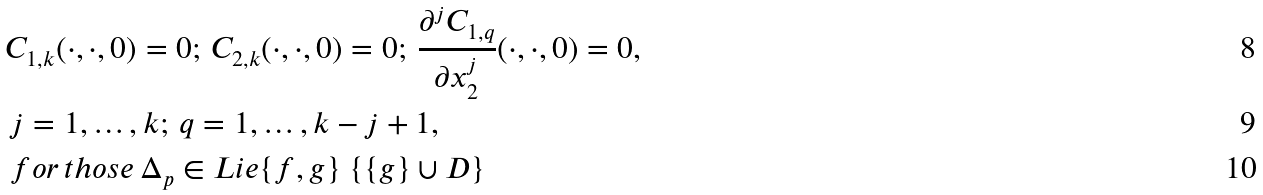Convert formula to latex. <formula><loc_0><loc_0><loc_500><loc_500>& C _ { 1 , k } ( \cdot , \cdot , 0 ) = 0 ; \, C _ { 2 , k } ( \cdot , \cdot , 0 ) = 0 ; \, \frac { \partial ^ { j } C _ { 1 , q } } { \partial x ^ { j } _ { 2 } } ( \cdot , \cdot , 0 ) = 0 , \\ & \, j = 1 , \dots , k ; \, q = 1 , \dots , k - j + 1 , \\ & \, f o r \, t h o s e \, \Delta _ { p } \in L i e \{ f , g \} \ \{ \{ g \} \cup D \}</formula> 